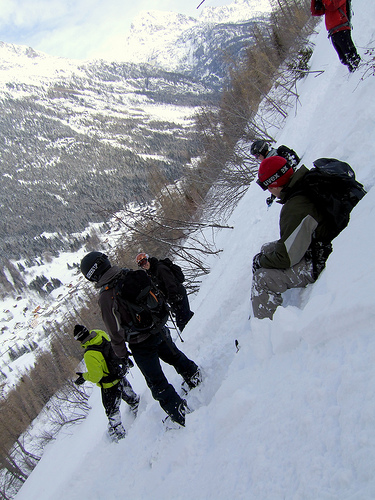<image>
Can you confirm if the guy is in front of the guy? Yes. The guy is positioned in front of the guy, appearing closer to the camera viewpoint. 